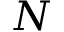Convert formula to latex. <formula><loc_0><loc_0><loc_500><loc_500>N</formula> 